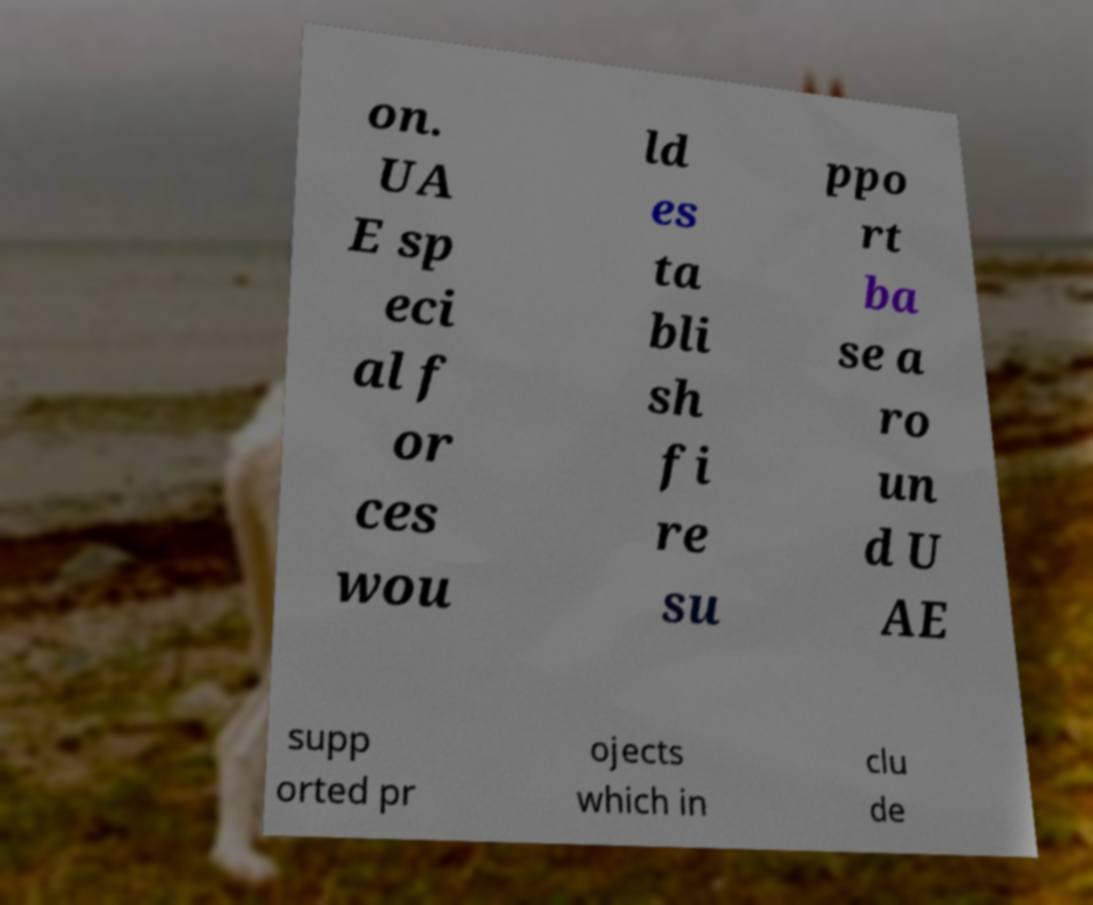For documentation purposes, I need the text within this image transcribed. Could you provide that? on. UA E sp eci al f or ces wou ld es ta bli sh fi re su ppo rt ba se a ro un d U AE supp orted pr ojects which in clu de 